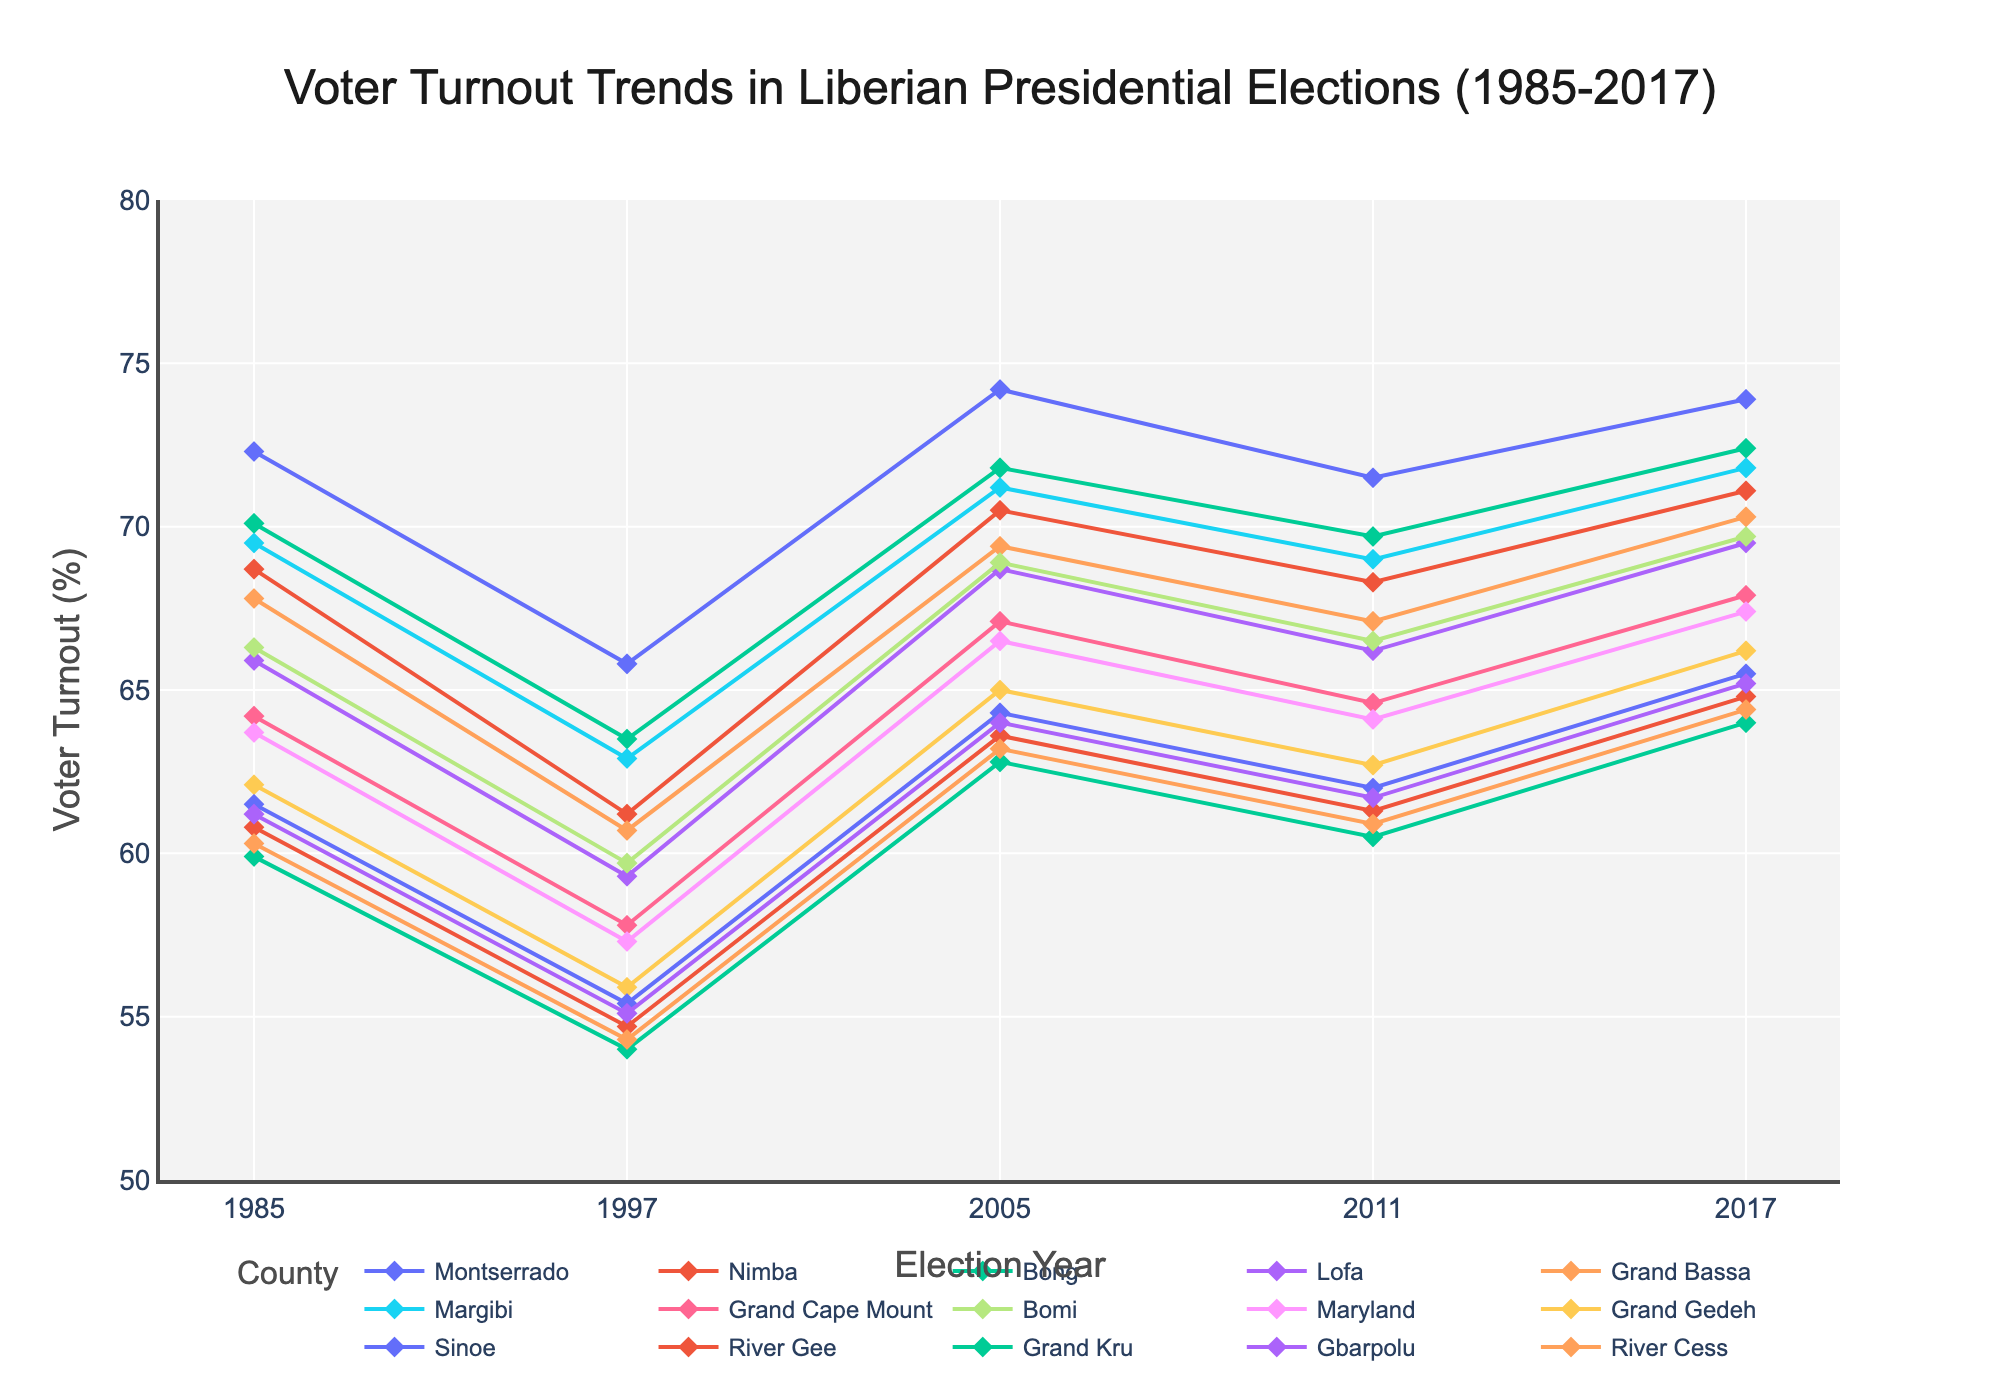What is the overall trend in voter turnout in Montserrado county from 1985 to 2017? The turnout in Montserrado showed a slight decrease in 1997, followed by an upward trend from 2005 to 2017, indicating overall increases in election years.
Answer: Increases overall Which county had the lowest voter turnout in the 1985 election? By looking at the 1985 voter turnout values for all the counties, Grand Kru had the lowest turnout.
Answer: Grand Kru In the 2017 election, compare the voter turnout of Bong and Margibi counties. Which one was higher? The voter turnout in Bong in 2017 was 72.4%, whereas in Margibi it was 71.8%. Therefore, Bong had a higher turnout.
Answer: Bong For Grand Bassa county, which election year saw the largest increase in voter turnout compared to the previous election? To find the largest increase, compare the difference in voter turnout between consecutive elections: 1985-1997 (-7.1), 1997-2005 (+8.7), 2005-2011 (-2.3), 2011-2017 (+3.2). The largest increase was from 1997 to 2005.
Answer: 1997-2005 Which counties had a turnout below 65% in 1997, and how many such counties are there? Counties with turnout below 65% in 1997 include Lofa, Grand Bassa, Grand Cape Mount, Bomi, Maryland, Grand Gedeh, Sinoe, River Gee, Grand Kru, Gbarpolu, and River Cess, totaling 11 counties.
Answer: 11 counties What is the average voter turnout for Nimba county across all the given election years? To calculate the average: (68.7 + 61.2 + 70.5 + 68.3 + 71.1) / 5 = 67.96%
Answer: 67.96% Which county shows the most consistent voter turnout (least variation in values) from 1985 to 2017? By examining and comparing the fluctuations in turnout for each county, Montserrado shows relatively small changes and thus the most consistent turnout.
Answer: Montserrado Did any county experience a continuous increase in voter turnout from 1997 to 2017? Montserrado's turnout increased from 1997 (65.8%) to 2005 (74.2%), then decreased slightly in 2011 (71.5%), and rose again in 2017 (73.9%), showing non-continuous growth. However, Bong showed uninterrupted increase from 1997 (63.5%) to 2017 (72.4%).
Answer: Bong Which county had the highest voter turnout in the 2011 election? Refer to the 2011 turnout values for the highest number, which is Montserrado at 71.5%.
Answer: Montserrado 